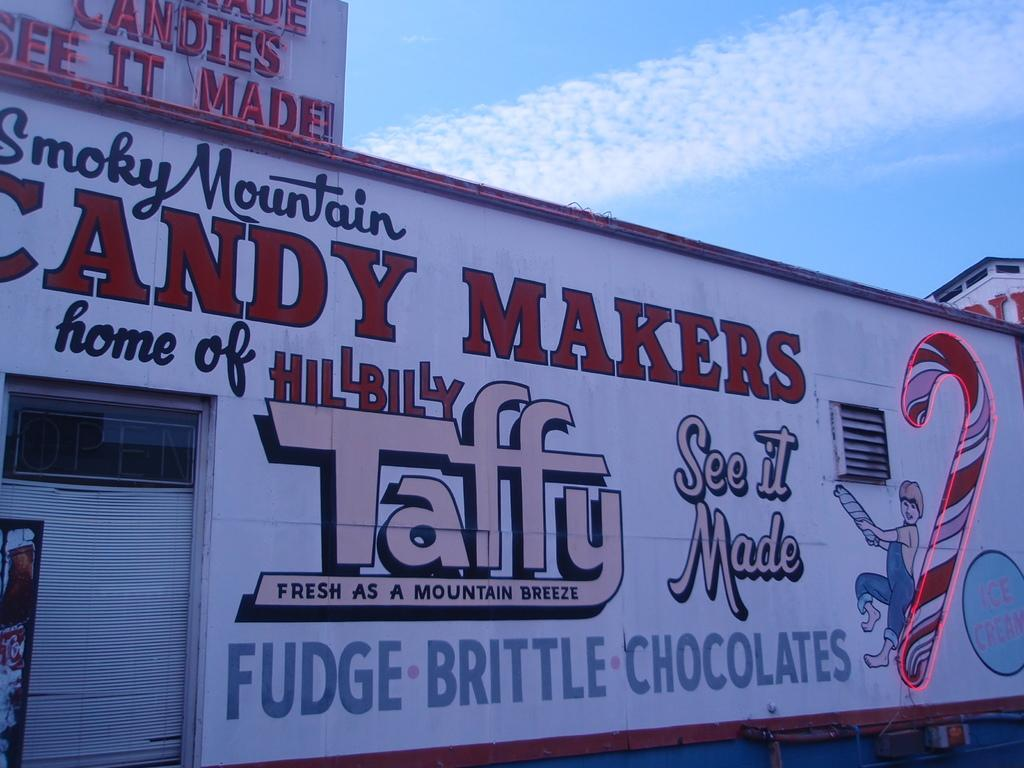What is located in the foreground of the picture? There is a wall in the foreground of the picture. What is written or depicted on the wall? There is text on the wall. What architectural feature can be seen on the left side of the picture? There is a door on the left side of the picture. How would you describe the weather based on the sky in the image? The sky is sunny in the image. Can you see a pickle hanging from the door in the image? There is no pickle present in the image, and it is not hanging from the door. Is there a rat visible in the image, trying to twist the door handle? There is no rat present in the image, and no one is attempting to twist the door handle. 